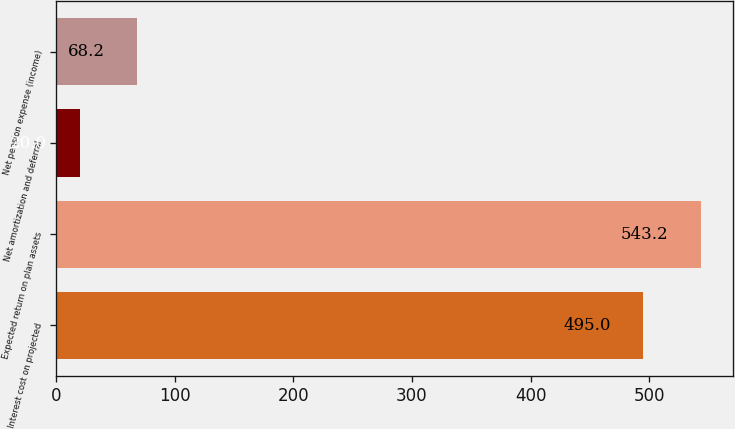<chart> <loc_0><loc_0><loc_500><loc_500><bar_chart><fcel>Interest cost on projected<fcel>Expected return on plan assets<fcel>Net amortization and deferral<fcel>Net pension expense (income)<nl><fcel>495<fcel>543.2<fcel>20<fcel>68.2<nl></chart> 